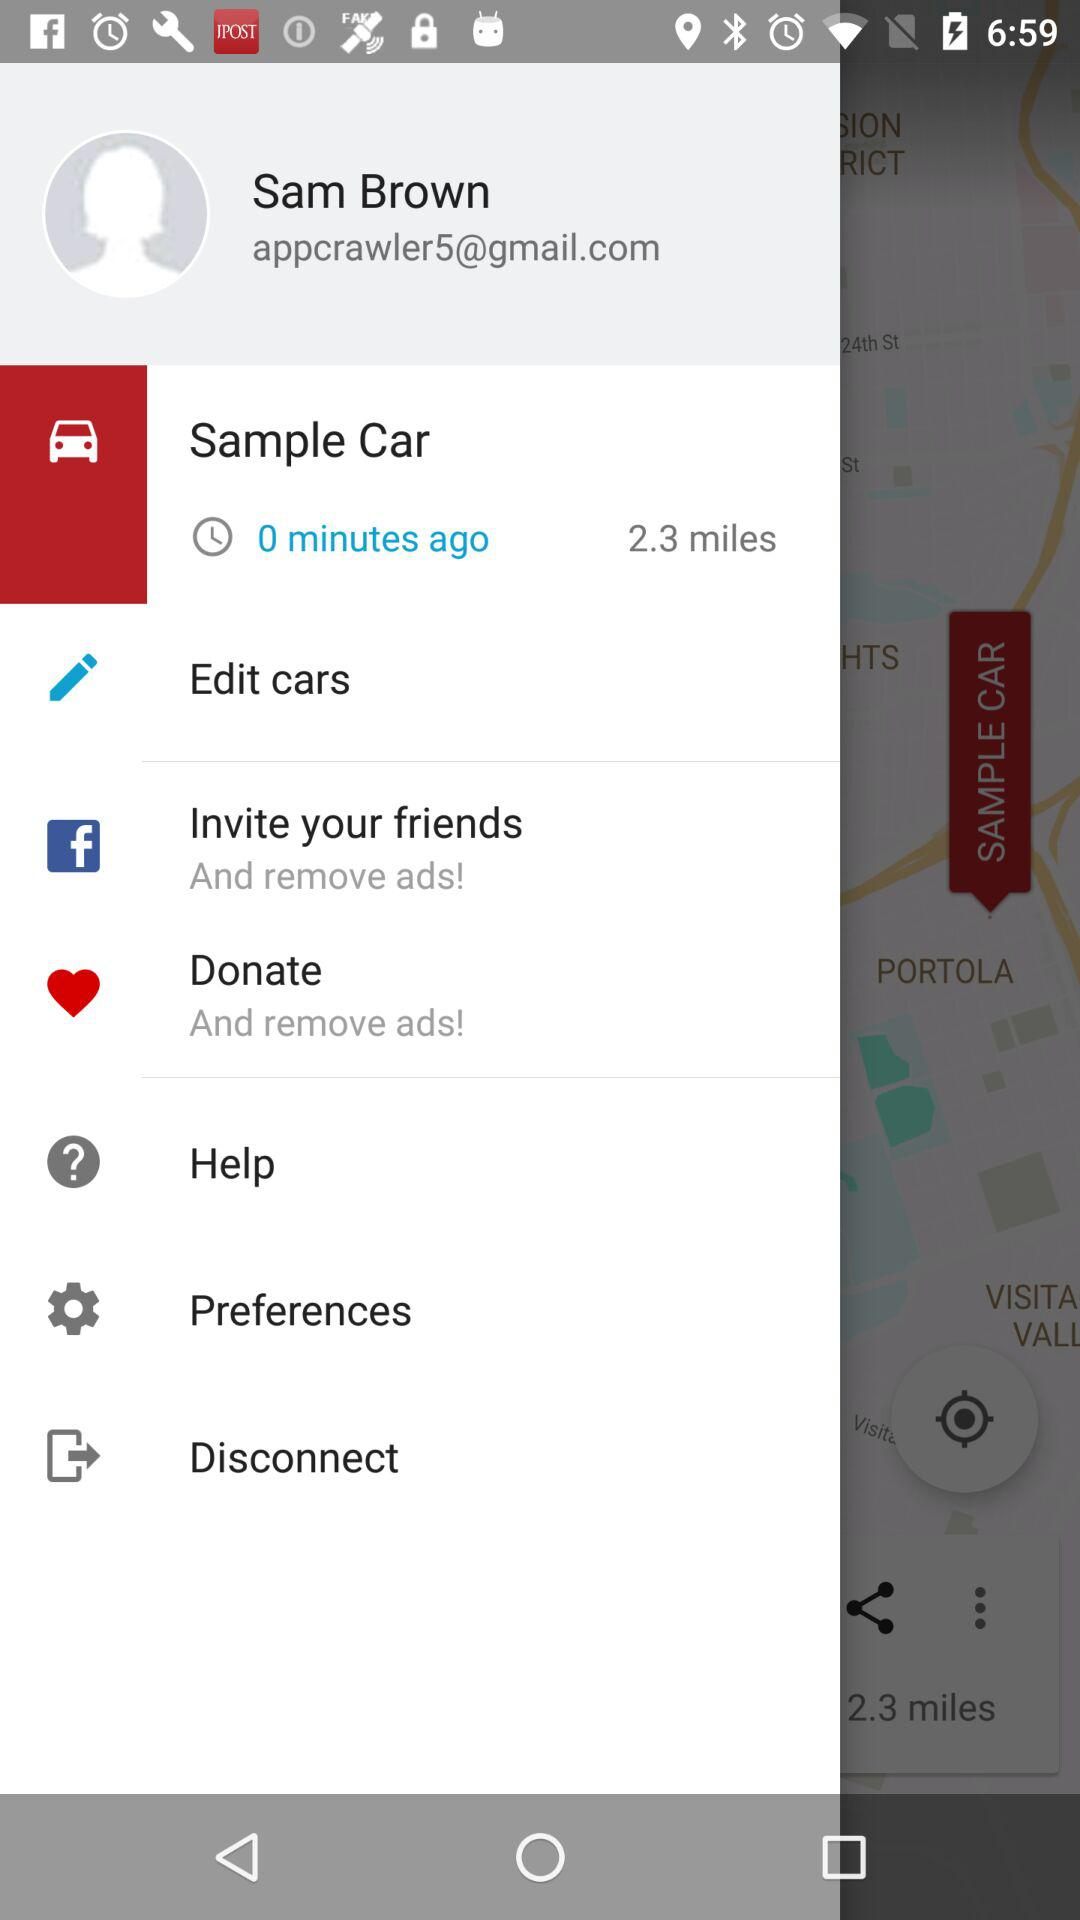How many miles are there for "Sample Car"? There are 2.3 miles for a "Sample Car". 